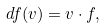Convert formula to latex. <formula><loc_0><loc_0><loc_500><loc_500>d f ( v ) = v \cdot f ,</formula> 